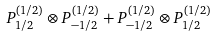<formula> <loc_0><loc_0><loc_500><loc_500>P _ { 1 / 2 } ^ { ( 1 / 2 ) } \otimes P _ { - 1 / 2 } ^ { ( 1 / 2 ) } + P _ { - 1 / 2 } ^ { ( 1 / 2 ) } \otimes P _ { 1 / 2 } ^ { ( 1 / 2 ) }</formula> 